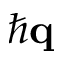<formula> <loc_0><loc_0><loc_500><loc_500>\hbar { q }</formula> 